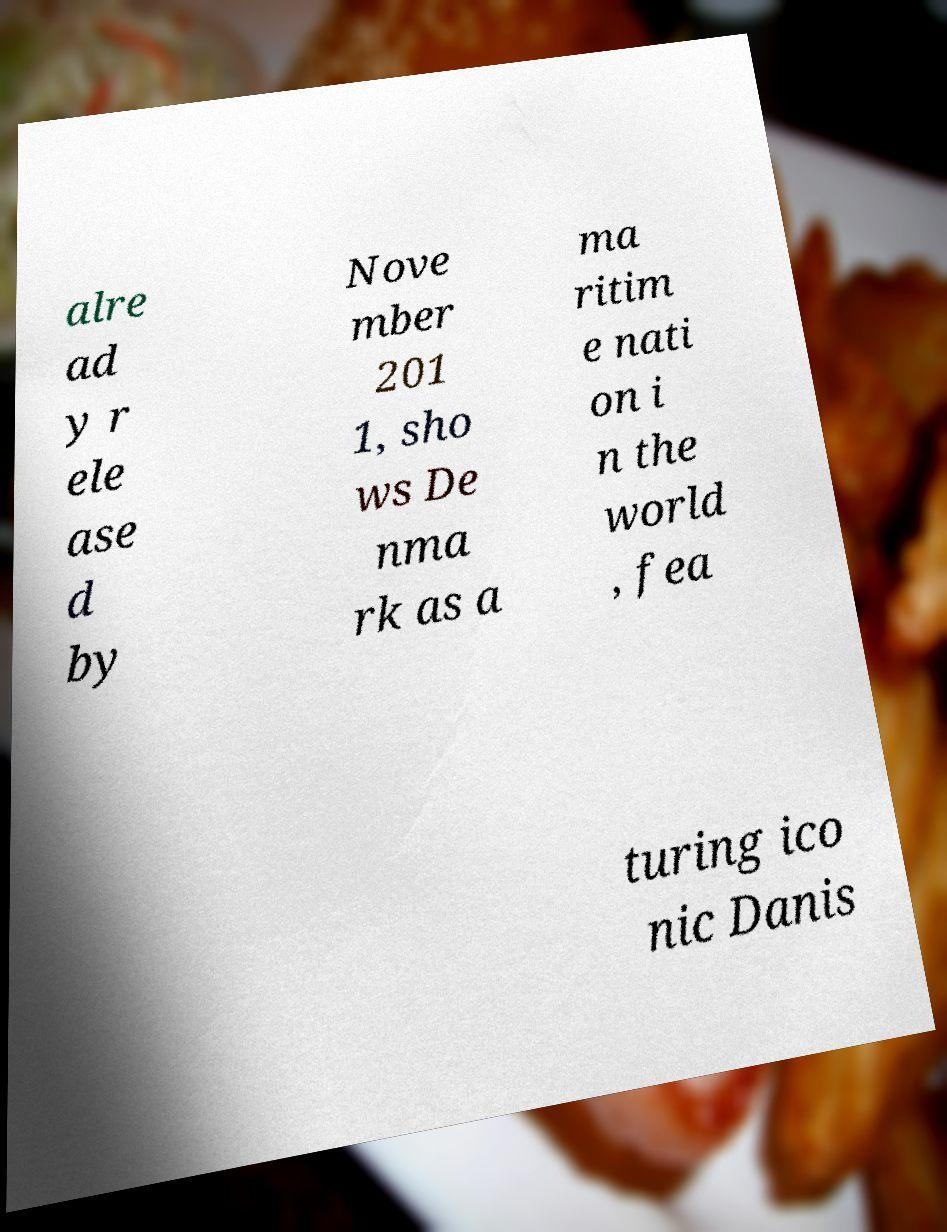Can you accurately transcribe the text from the provided image for me? alre ad y r ele ase d by Nove mber 201 1, sho ws De nma rk as a ma ritim e nati on i n the world , fea turing ico nic Danis 